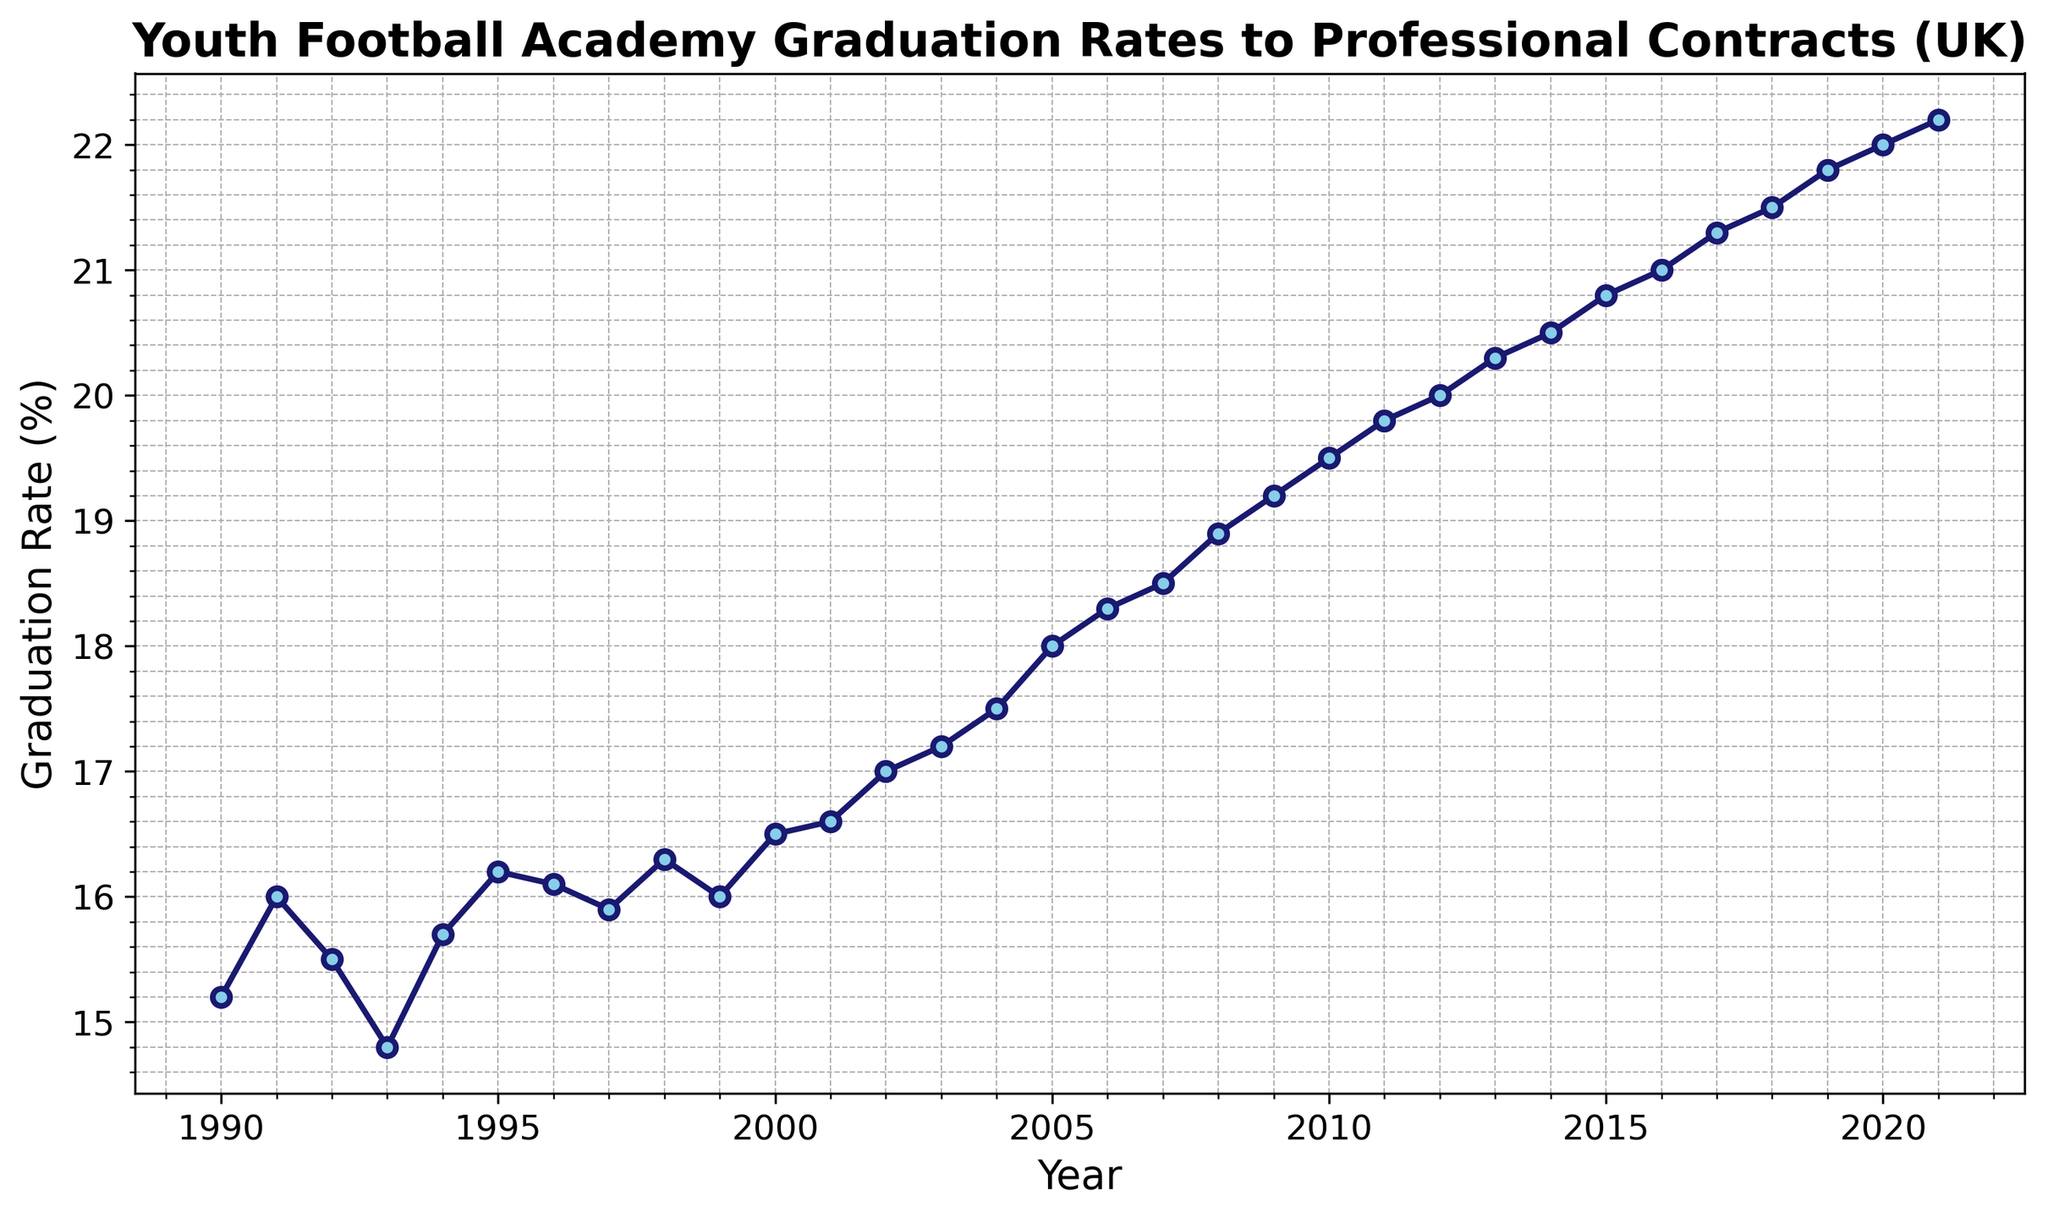What was the graduation rate in 1995? Look for the data point that aligns with the year 1995 on the x-axis and read off the corresponding value on the y-axis.
Answer: 16.2 Between which consecutive years was there the largest increase in graduation rate? Examine the slope of the line segments connecting each year; the steepest slope will indicate the largest increase. Identify these years.
Answer: 2009 and 2010 How much did the graduation rate increase from 1990 to 2000? Subtract the graduation rate in 1990 from the rate in 2000. (16.5 - 15.2) = 1.3
Answer: 1.3 Which year has the highest graduation rate? Locate the maximum value on the y-axis and identify the corresponding year on the x-axis.
Answer: 2021 Describe the trend in the graduation rate from 2002 to 2021. Observe the general direction of the line from 2002 to 2021. It shows an upward trend indicating an increasing graduation rate over these years.
Answer: Increasing What is the average graduation rate over the entire period? Add all the graduation rates from 1990 to 2021 and divide by the number of years (which is 32). The values sum up to 553.1, so the average is 553.1/32 = 17.28
Answer: 17.28 In which decade did the graduation rate increase the most? Compare the starting and ending graduation rates of each decade and calculate the differences: 1990s (1.1), 2000s (2.9), 2010s (2.2). The differences show the 2000s had the greatest increase.
Answer: 2000s How did the graduation rate change from 1991 to 1993? Identify the graduation rates for 1991 (16.0) and 1993 (14.8) and find the difference (16.0 - 14.8 = 1.2).
Answer: Decreased by 1.2 Is there any observable pattern in the graduation rate changes during the 1990s? Look at the specific graduation rates each year and describe the overall trend. Rates in the 1990s show slight fluctuations but remain relatively steady within a range of approximately 15.2 to 16.5.
Answer: Relatively steady with slight fluctuations 